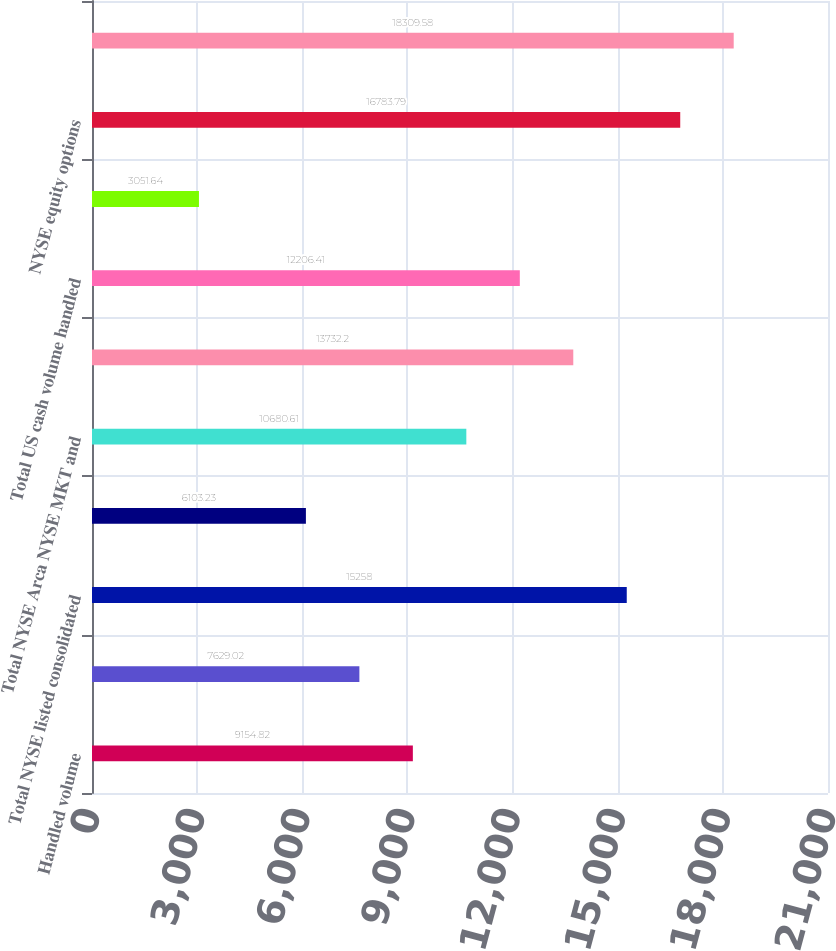<chart> <loc_0><loc_0><loc_500><loc_500><bar_chart><fcel>Handled volume<fcel>Matched volume<fcel>Total NYSE listed consolidated<fcel>Share of total matched<fcel>Total NYSE Arca NYSE MKT and<fcel>Total Nasdaq listed<fcel>Total US cash volume handled<fcel>Total US cash market share<fcel>NYSE equity options<fcel>Total US equity options volume<nl><fcel>9154.82<fcel>7629.02<fcel>15258<fcel>6103.23<fcel>10680.6<fcel>13732.2<fcel>12206.4<fcel>3051.64<fcel>16783.8<fcel>18309.6<nl></chart> 